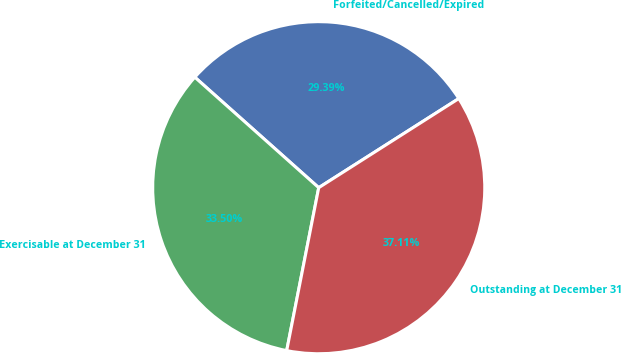Convert chart. <chart><loc_0><loc_0><loc_500><loc_500><pie_chart><fcel>Forfeited/Cancelled/Expired<fcel>Exercisable at December 31<fcel>Outstanding at December 31<nl><fcel>29.39%<fcel>33.5%<fcel>37.11%<nl></chart> 